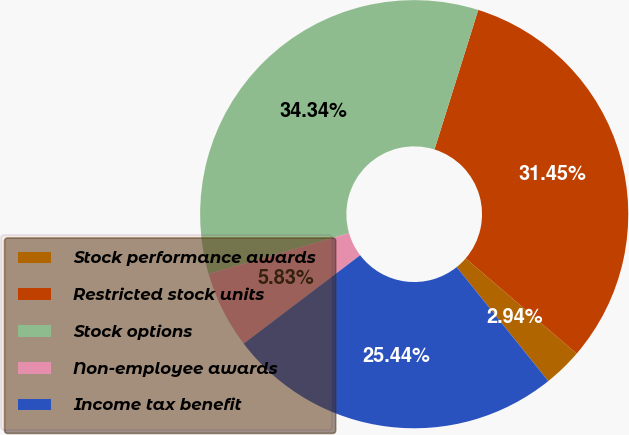<chart> <loc_0><loc_0><loc_500><loc_500><pie_chart><fcel>Stock performance awards<fcel>Restricted stock units<fcel>Stock options<fcel>Non-employee awards<fcel>Income tax benefit<nl><fcel>2.94%<fcel>31.45%<fcel>34.34%<fcel>5.83%<fcel>25.44%<nl></chart> 